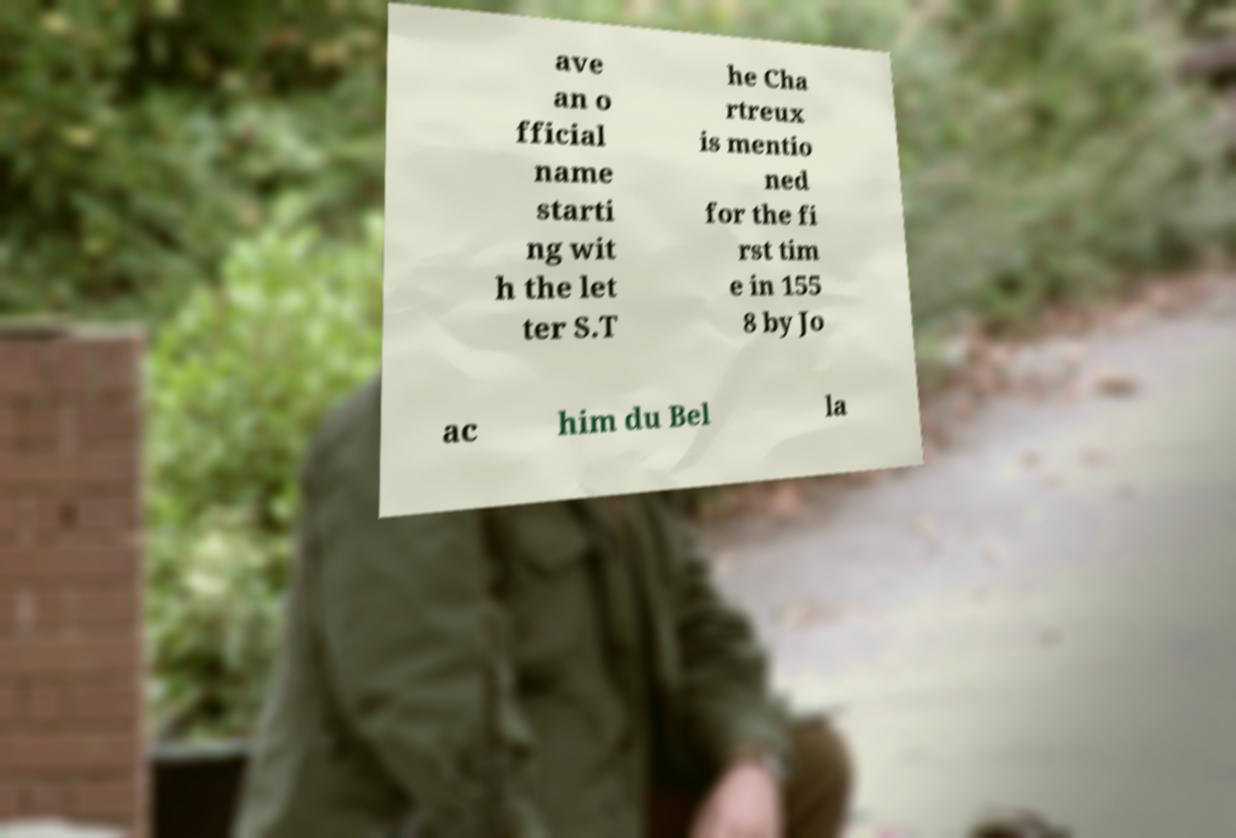For documentation purposes, I need the text within this image transcribed. Could you provide that? ave an o fficial name starti ng wit h the let ter S.T he Cha rtreux is mentio ned for the fi rst tim e in 155 8 by Jo ac him du Bel la 